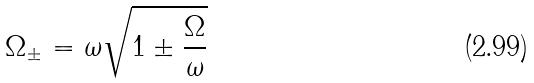Convert formula to latex. <formula><loc_0><loc_0><loc_500><loc_500>\Omega _ { \pm } = \omega \sqrt { 1 \pm \frac { \Omega } { \omega } }</formula> 